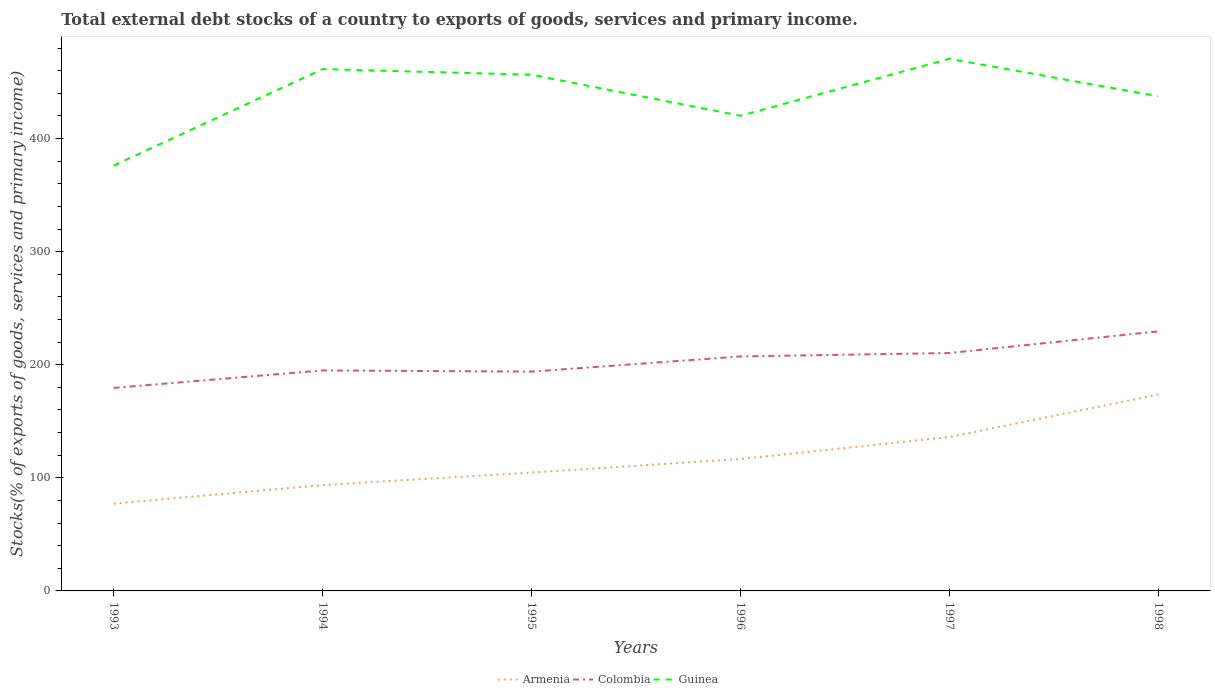Does the line corresponding to Guinea intersect with the line corresponding to Armenia?
Give a very brief answer. No. Is the number of lines equal to the number of legend labels?
Offer a very short reply. Yes. Across all years, what is the maximum total debt stocks in Guinea?
Provide a short and direct response. 376.23. What is the total total debt stocks in Armenia in the graph?
Your answer should be compact. -68.98. What is the difference between the highest and the second highest total debt stocks in Armenia?
Your answer should be compact. 96.45. What is the difference between the highest and the lowest total debt stocks in Armenia?
Provide a succinct answer. 2. How many years are there in the graph?
Your answer should be compact. 6. What is the title of the graph?
Ensure brevity in your answer.  Total external debt stocks of a country to exports of goods, services and primary income. What is the label or title of the X-axis?
Keep it short and to the point. Years. What is the label or title of the Y-axis?
Provide a succinct answer. Stocks(% of exports of goods, services and primary income). What is the Stocks(% of exports of goods, services and primary income) in Armenia in 1993?
Keep it short and to the point. 77.2. What is the Stocks(% of exports of goods, services and primary income) of Colombia in 1993?
Give a very brief answer. 179.52. What is the Stocks(% of exports of goods, services and primary income) of Guinea in 1993?
Make the answer very short. 376.23. What is the Stocks(% of exports of goods, services and primary income) of Armenia in 1994?
Ensure brevity in your answer.  93.59. What is the Stocks(% of exports of goods, services and primary income) in Colombia in 1994?
Give a very brief answer. 194.99. What is the Stocks(% of exports of goods, services and primary income) in Guinea in 1994?
Your answer should be compact. 461.48. What is the Stocks(% of exports of goods, services and primary income) in Armenia in 1995?
Your answer should be compact. 104.67. What is the Stocks(% of exports of goods, services and primary income) in Colombia in 1995?
Your answer should be very brief. 193.93. What is the Stocks(% of exports of goods, services and primary income) in Guinea in 1995?
Your response must be concise. 456.52. What is the Stocks(% of exports of goods, services and primary income) of Armenia in 1996?
Offer a terse response. 116.66. What is the Stocks(% of exports of goods, services and primary income) of Colombia in 1996?
Keep it short and to the point. 207.36. What is the Stocks(% of exports of goods, services and primary income) of Guinea in 1996?
Ensure brevity in your answer.  420.25. What is the Stocks(% of exports of goods, services and primary income) in Armenia in 1997?
Provide a short and direct response. 136.08. What is the Stocks(% of exports of goods, services and primary income) in Colombia in 1997?
Ensure brevity in your answer.  210.38. What is the Stocks(% of exports of goods, services and primary income) of Guinea in 1997?
Provide a succinct answer. 470.56. What is the Stocks(% of exports of goods, services and primary income) in Armenia in 1998?
Provide a succinct answer. 173.65. What is the Stocks(% of exports of goods, services and primary income) of Colombia in 1998?
Make the answer very short. 229.54. What is the Stocks(% of exports of goods, services and primary income) in Guinea in 1998?
Your answer should be very brief. 437.52. Across all years, what is the maximum Stocks(% of exports of goods, services and primary income) in Armenia?
Give a very brief answer. 173.65. Across all years, what is the maximum Stocks(% of exports of goods, services and primary income) in Colombia?
Ensure brevity in your answer.  229.54. Across all years, what is the maximum Stocks(% of exports of goods, services and primary income) in Guinea?
Keep it short and to the point. 470.56. Across all years, what is the minimum Stocks(% of exports of goods, services and primary income) of Armenia?
Offer a terse response. 77.2. Across all years, what is the minimum Stocks(% of exports of goods, services and primary income) of Colombia?
Offer a very short reply. 179.52. Across all years, what is the minimum Stocks(% of exports of goods, services and primary income) in Guinea?
Ensure brevity in your answer.  376.23. What is the total Stocks(% of exports of goods, services and primary income) of Armenia in the graph?
Your answer should be compact. 701.85. What is the total Stocks(% of exports of goods, services and primary income) in Colombia in the graph?
Your response must be concise. 1215.72. What is the total Stocks(% of exports of goods, services and primary income) of Guinea in the graph?
Keep it short and to the point. 2622.56. What is the difference between the Stocks(% of exports of goods, services and primary income) in Armenia in 1993 and that in 1994?
Give a very brief answer. -16.38. What is the difference between the Stocks(% of exports of goods, services and primary income) in Colombia in 1993 and that in 1994?
Ensure brevity in your answer.  -15.47. What is the difference between the Stocks(% of exports of goods, services and primary income) of Guinea in 1993 and that in 1994?
Keep it short and to the point. -85.24. What is the difference between the Stocks(% of exports of goods, services and primary income) of Armenia in 1993 and that in 1995?
Give a very brief answer. -27.46. What is the difference between the Stocks(% of exports of goods, services and primary income) in Colombia in 1993 and that in 1995?
Offer a terse response. -14.4. What is the difference between the Stocks(% of exports of goods, services and primary income) of Guinea in 1993 and that in 1995?
Ensure brevity in your answer.  -80.29. What is the difference between the Stocks(% of exports of goods, services and primary income) of Armenia in 1993 and that in 1996?
Give a very brief answer. -39.46. What is the difference between the Stocks(% of exports of goods, services and primary income) in Colombia in 1993 and that in 1996?
Your response must be concise. -27.84. What is the difference between the Stocks(% of exports of goods, services and primary income) of Guinea in 1993 and that in 1996?
Make the answer very short. -44.02. What is the difference between the Stocks(% of exports of goods, services and primary income) of Armenia in 1993 and that in 1997?
Keep it short and to the point. -58.88. What is the difference between the Stocks(% of exports of goods, services and primary income) in Colombia in 1993 and that in 1997?
Keep it short and to the point. -30.86. What is the difference between the Stocks(% of exports of goods, services and primary income) in Guinea in 1993 and that in 1997?
Ensure brevity in your answer.  -94.32. What is the difference between the Stocks(% of exports of goods, services and primary income) in Armenia in 1993 and that in 1998?
Make the answer very short. -96.45. What is the difference between the Stocks(% of exports of goods, services and primary income) in Colombia in 1993 and that in 1998?
Provide a succinct answer. -50.01. What is the difference between the Stocks(% of exports of goods, services and primary income) of Guinea in 1993 and that in 1998?
Ensure brevity in your answer.  -61.28. What is the difference between the Stocks(% of exports of goods, services and primary income) in Armenia in 1994 and that in 1995?
Give a very brief answer. -11.08. What is the difference between the Stocks(% of exports of goods, services and primary income) in Colombia in 1994 and that in 1995?
Give a very brief answer. 1.07. What is the difference between the Stocks(% of exports of goods, services and primary income) of Guinea in 1994 and that in 1995?
Ensure brevity in your answer.  4.95. What is the difference between the Stocks(% of exports of goods, services and primary income) of Armenia in 1994 and that in 1996?
Ensure brevity in your answer.  -23.08. What is the difference between the Stocks(% of exports of goods, services and primary income) in Colombia in 1994 and that in 1996?
Make the answer very short. -12.37. What is the difference between the Stocks(% of exports of goods, services and primary income) in Guinea in 1994 and that in 1996?
Your answer should be compact. 41.23. What is the difference between the Stocks(% of exports of goods, services and primary income) of Armenia in 1994 and that in 1997?
Give a very brief answer. -42.5. What is the difference between the Stocks(% of exports of goods, services and primary income) in Colombia in 1994 and that in 1997?
Your response must be concise. -15.39. What is the difference between the Stocks(% of exports of goods, services and primary income) of Guinea in 1994 and that in 1997?
Give a very brief answer. -9.08. What is the difference between the Stocks(% of exports of goods, services and primary income) in Armenia in 1994 and that in 1998?
Keep it short and to the point. -80.06. What is the difference between the Stocks(% of exports of goods, services and primary income) of Colombia in 1994 and that in 1998?
Your response must be concise. -34.54. What is the difference between the Stocks(% of exports of goods, services and primary income) in Guinea in 1994 and that in 1998?
Provide a short and direct response. 23.96. What is the difference between the Stocks(% of exports of goods, services and primary income) in Armenia in 1995 and that in 1996?
Give a very brief answer. -12. What is the difference between the Stocks(% of exports of goods, services and primary income) in Colombia in 1995 and that in 1996?
Your answer should be compact. -13.44. What is the difference between the Stocks(% of exports of goods, services and primary income) of Guinea in 1995 and that in 1996?
Ensure brevity in your answer.  36.27. What is the difference between the Stocks(% of exports of goods, services and primary income) in Armenia in 1995 and that in 1997?
Make the answer very short. -31.42. What is the difference between the Stocks(% of exports of goods, services and primary income) of Colombia in 1995 and that in 1997?
Provide a succinct answer. -16.46. What is the difference between the Stocks(% of exports of goods, services and primary income) in Guinea in 1995 and that in 1997?
Make the answer very short. -14.03. What is the difference between the Stocks(% of exports of goods, services and primary income) in Armenia in 1995 and that in 1998?
Offer a very short reply. -68.98. What is the difference between the Stocks(% of exports of goods, services and primary income) in Colombia in 1995 and that in 1998?
Offer a very short reply. -35.61. What is the difference between the Stocks(% of exports of goods, services and primary income) of Guinea in 1995 and that in 1998?
Provide a succinct answer. 19.01. What is the difference between the Stocks(% of exports of goods, services and primary income) of Armenia in 1996 and that in 1997?
Make the answer very short. -19.42. What is the difference between the Stocks(% of exports of goods, services and primary income) of Colombia in 1996 and that in 1997?
Ensure brevity in your answer.  -3.02. What is the difference between the Stocks(% of exports of goods, services and primary income) of Guinea in 1996 and that in 1997?
Provide a succinct answer. -50.3. What is the difference between the Stocks(% of exports of goods, services and primary income) of Armenia in 1996 and that in 1998?
Keep it short and to the point. -56.99. What is the difference between the Stocks(% of exports of goods, services and primary income) of Colombia in 1996 and that in 1998?
Make the answer very short. -22.17. What is the difference between the Stocks(% of exports of goods, services and primary income) in Guinea in 1996 and that in 1998?
Ensure brevity in your answer.  -17.26. What is the difference between the Stocks(% of exports of goods, services and primary income) in Armenia in 1997 and that in 1998?
Your answer should be compact. -37.57. What is the difference between the Stocks(% of exports of goods, services and primary income) of Colombia in 1997 and that in 1998?
Your answer should be very brief. -19.15. What is the difference between the Stocks(% of exports of goods, services and primary income) of Guinea in 1997 and that in 1998?
Offer a very short reply. 33.04. What is the difference between the Stocks(% of exports of goods, services and primary income) in Armenia in 1993 and the Stocks(% of exports of goods, services and primary income) in Colombia in 1994?
Make the answer very short. -117.79. What is the difference between the Stocks(% of exports of goods, services and primary income) in Armenia in 1993 and the Stocks(% of exports of goods, services and primary income) in Guinea in 1994?
Provide a short and direct response. -384.28. What is the difference between the Stocks(% of exports of goods, services and primary income) of Colombia in 1993 and the Stocks(% of exports of goods, services and primary income) of Guinea in 1994?
Make the answer very short. -281.95. What is the difference between the Stocks(% of exports of goods, services and primary income) in Armenia in 1993 and the Stocks(% of exports of goods, services and primary income) in Colombia in 1995?
Give a very brief answer. -116.72. What is the difference between the Stocks(% of exports of goods, services and primary income) in Armenia in 1993 and the Stocks(% of exports of goods, services and primary income) in Guinea in 1995?
Provide a succinct answer. -379.32. What is the difference between the Stocks(% of exports of goods, services and primary income) of Colombia in 1993 and the Stocks(% of exports of goods, services and primary income) of Guinea in 1995?
Ensure brevity in your answer.  -277. What is the difference between the Stocks(% of exports of goods, services and primary income) of Armenia in 1993 and the Stocks(% of exports of goods, services and primary income) of Colombia in 1996?
Make the answer very short. -130.16. What is the difference between the Stocks(% of exports of goods, services and primary income) in Armenia in 1993 and the Stocks(% of exports of goods, services and primary income) in Guinea in 1996?
Keep it short and to the point. -343.05. What is the difference between the Stocks(% of exports of goods, services and primary income) in Colombia in 1993 and the Stocks(% of exports of goods, services and primary income) in Guinea in 1996?
Provide a succinct answer. -240.73. What is the difference between the Stocks(% of exports of goods, services and primary income) of Armenia in 1993 and the Stocks(% of exports of goods, services and primary income) of Colombia in 1997?
Offer a very short reply. -133.18. What is the difference between the Stocks(% of exports of goods, services and primary income) of Armenia in 1993 and the Stocks(% of exports of goods, services and primary income) of Guinea in 1997?
Your response must be concise. -393.35. What is the difference between the Stocks(% of exports of goods, services and primary income) of Colombia in 1993 and the Stocks(% of exports of goods, services and primary income) of Guinea in 1997?
Ensure brevity in your answer.  -291.03. What is the difference between the Stocks(% of exports of goods, services and primary income) in Armenia in 1993 and the Stocks(% of exports of goods, services and primary income) in Colombia in 1998?
Give a very brief answer. -152.33. What is the difference between the Stocks(% of exports of goods, services and primary income) in Armenia in 1993 and the Stocks(% of exports of goods, services and primary income) in Guinea in 1998?
Keep it short and to the point. -360.31. What is the difference between the Stocks(% of exports of goods, services and primary income) in Colombia in 1993 and the Stocks(% of exports of goods, services and primary income) in Guinea in 1998?
Ensure brevity in your answer.  -257.99. What is the difference between the Stocks(% of exports of goods, services and primary income) of Armenia in 1994 and the Stocks(% of exports of goods, services and primary income) of Colombia in 1995?
Keep it short and to the point. -100.34. What is the difference between the Stocks(% of exports of goods, services and primary income) of Armenia in 1994 and the Stocks(% of exports of goods, services and primary income) of Guinea in 1995?
Make the answer very short. -362.94. What is the difference between the Stocks(% of exports of goods, services and primary income) in Colombia in 1994 and the Stocks(% of exports of goods, services and primary income) in Guinea in 1995?
Keep it short and to the point. -261.53. What is the difference between the Stocks(% of exports of goods, services and primary income) in Armenia in 1994 and the Stocks(% of exports of goods, services and primary income) in Colombia in 1996?
Ensure brevity in your answer.  -113.78. What is the difference between the Stocks(% of exports of goods, services and primary income) of Armenia in 1994 and the Stocks(% of exports of goods, services and primary income) of Guinea in 1996?
Provide a short and direct response. -326.67. What is the difference between the Stocks(% of exports of goods, services and primary income) of Colombia in 1994 and the Stocks(% of exports of goods, services and primary income) of Guinea in 1996?
Your response must be concise. -225.26. What is the difference between the Stocks(% of exports of goods, services and primary income) in Armenia in 1994 and the Stocks(% of exports of goods, services and primary income) in Colombia in 1997?
Your answer should be compact. -116.8. What is the difference between the Stocks(% of exports of goods, services and primary income) of Armenia in 1994 and the Stocks(% of exports of goods, services and primary income) of Guinea in 1997?
Provide a succinct answer. -376.97. What is the difference between the Stocks(% of exports of goods, services and primary income) in Colombia in 1994 and the Stocks(% of exports of goods, services and primary income) in Guinea in 1997?
Provide a succinct answer. -275.56. What is the difference between the Stocks(% of exports of goods, services and primary income) in Armenia in 1994 and the Stocks(% of exports of goods, services and primary income) in Colombia in 1998?
Make the answer very short. -135.95. What is the difference between the Stocks(% of exports of goods, services and primary income) in Armenia in 1994 and the Stocks(% of exports of goods, services and primary income) in Guinea in 1998?
Offer a terse response. -343.93. What is the difference between the Stocks(% of exports of goods, services and primary income) of Colombia in 1994 and the Stocks(% of exports of goods, services and primary income) of Guinea in 1998?
Ensure brevity in your answer.  -242.52. What is the difference between the Stocks(% of exports of goods, services and primary income) of Armenia in 1995 and the Stocks(% of exports of goods, services and primary income) of Colombia in 1996?
Keep it short and to the point. -102.7. What is the difference between the Stocks(% of exports of goods, services and primary income) in Armenia in 1995 and the Stocks(% of exports of goods, services and primary income) in Guinea in 1996?
Offer a terse response. -315.59. What is the difference between the Stocks(% of exports of goods, services and primary income) of Colombia in 1995 and the Stocks(% of exports of goods, services and primary income) of Guinea in 1996?
Your answer should be very brief. -226.33. What is the difference between the Stocks(% of exports of goods, services and primary income) of Armenia in 1995 and the Stocks(% of exports of goods, services and primary income) of Colombia in 1997?
Provide a short and direct response. -105.72. What is the difference between the Stocks(% of exports of goods, services and primary income) of Armenia in 1995 and the Stocks(% of exports of goods, services and primary income) of Guinea in 1997?
Offer a terse response. -365.89. What is the difference between the Stocks(% of exports of goods, services and primary income) of Colombia in 1995 and the Stocks(% of exports of goods, services and primary income) of Guinea in 1997?
Your response must be concise. -276.63. What is the difference between the Stocks(% of exports of goods, services and primary income) in Armenia in 1995 and the Stocks(% of exports of goods, services and primary income) in Colombia in 1998?
Provide a succinct answer. -124.87. What is the difference between the Stocks(% of exports of goods, services and primary income) in Armenia in 1995 and the Stocks(% of exports of goods, services and primary income) in Guinea in 1998?
Provide a succinct answer. -332.85. What is the difference between the Stocks(% of exports of goods, services and primary income) in Colombia in 1995 and the Stocks(% of exports of goods, services and primary income) in Guinea in 1998?
Offer a terse response. -243.59. What is the difference between the Stocks(% of exports of goods, services and primary income) of Armenia in 1996 and the Stocks(% of exports of goods, services and primary income) of Colombia in 1997?
Your answer should be compact. -93.72. What is the difference between the Stocks(% of exports of goods, services and primary income) of Armenia in 1996 and the Stocks(% of exports of goods, services and primary income) of Guinea in 1997?
Keep it short and to the point. -353.89. What is the difference between the Stocks(% of exports of goods, services and primary income) of Colombia in 1996 and the Stocks(% of exports of goods, services and primary income) of Guinea in 1997?
Your answer should be very brief. -263.19. What is the difference between the Stocks(% of exports of goods, services and primary income) in Armenia in 1996 and the Stocks(% of exports of goods, services and primary income) in Colombia in 1998?
Keep it short and to the point. -112.87. What is the difference between the Stocks(% of exports of goods, services and primary income) in Armenia in 1996 and the Stocks(% of exports of goods, services and primary income) in Guinea in 1998?
Your answer should be very brief. -320.85. What is the difference between the Stocks(% of exports of goods, services and primary income) in Colombia in 1996 and the Stocks(% of exports of goods, services and primary income) in Guinea in 1998?
Provide a succinct answer. -230.15. What is the difference between the Stocks(% of exports of goods, services and primary income) of Armenia in 1997 and the Stocks(% of exports of goods, services and primary income) of Colombia in 1998?
Your answer should be compact. -93.45. What is the difference between the Stocks(% of exports of goods, services and primary income) in Armenia in 1997 and the Stocks(% of exports of goods, services and primary income) in Guinea in 1998?
Make the answer very short. -301.43. What is the difference between the Stocks(% of exports of goods, services and primary income) in Colombia in 1997 and the Stocks(% of exports of goods, services and primary income) in Guinea in 1998?
Your response must be concise. -227.13. What is the average Stocks(% of exports of goods, services and primary income) in Armenia per year?
Give a very brief answer. 116.98. What is the average Stocks(% of exports of goods, services and primary income) in Colombia per year?
Provide a short and direct response. 202.62. What is the average Stocks(% of exports of goods, services and primary income) of Guinea per year?
Provide a short and direct response. 437.09. In the year 1993, what is the difference between the Stocks(% of exports of goods, services and primary income) in Armenia and Stocks(% of exports of goods, services and primary income) in Colombia?
Your response must be concise. -102.32. In the year 1993, what is the difference between the Stocks(% of exports of goods, services and primary income) of Armenia and Stocks(% of exports of goods, services and primary income) of Guinea?
Provide a short and direct response. -299.03. In the year 1993, what is the difference between the Stocks(% of exports of goods, services and primary income) in Colombia and Stocks(% of exports of goods, services and primary income) in Guinea?
Ensure brevity in your answer.  -196.71. In the year 1994, what is the difference between the Stocks(% of exports of goods, services and primary income) of Armenia and Stocks(% of exports of goods, services and primary income) of Colombia?
Your answer should be compact. -101.41. In the year 1994, what is the difference between the Stocks(% of exports of goods, services and primary income) of Armenia and Stocks(% of exports of goods, services and primary income) of Guinea?
Your response must be concise. -367.89. In the year 1994, what is the difference between the Stocks(% of exports of goods, services and primary income) in Colombia and Stocks(% of exports of goods, services and primary income) in Guinea?
Provide a succinct answer. -266.49. In the year 1995, what is the difference between the Stocks(% of exports of goods, services and primary income) of Armenia and Stocks(% of exports of goods, services and primary income) of Colombia?
Your response must be concise. -89.26. In the year 1995, what is the difference between the Stocks(% of exports of goods, services and primary income) of Armenia and Stocks(% of exports of goods, services and primary income) of Guinea?
Keep it short and to the point. -351.86. In the year 1995, what is the difference between the Stocks(% of exports of goods, services and primary income) in Colombia and Stocks(% of exports of goods, services and primary income) in Guinea?
Your response must be concise. -262.6. In the year 1996, what is the difference between the Stocks(% of exports of goods, services and primary income) of Armenia and Stocks(% of exports of goods, services and primary income) of Colombia?
Offer a very short reply. -90.7. In the year 1996, what is the difference between the Stocks(% of exports of goods, services and primary income) in Armenia and Stocks(% of exports of goods, services and primary income) in Guinea?
Offer a very short reply. -303.59. In the year 1996, what is the difference between the Stocks(% of exports of goods, services and primary income) in Colombia and Stocks(% of exports of goods, services and primary income) in Guinea?
Your response must be concise. -212.89. In the year 1997, what is the difference between the Stocks(% of exports of goods, services and primary income) of Armenia and Stocks(% of exports of goods, services and primary income) of Colombia?
Offer a very short reply. -74.3. In the year 1997, what is the difference between the Stocks(% of exports of goods, services and primary income) in Armenia and Stocks(% of exports of goods, services and primary income) in Guinea?
Offer a terse response. -334.47. In the year 1997, what is the difference between the Stocks(% of exports of goods, services and primary income) in Colombia and Stocks(% of exports of goods, services and primary income) in Guinea?
Offer a very short reply. -260.17. In the year 1998, what is the difference between the Stocks(% of exports of goods, services and primary income) in Armenia and Stocks(% of exports of goods, services and primary income) in Colombia?
Provide a succinct answer. -55.89. In the year 1998, what is the difference between the Stocks(% of exports of goods, services and primary income) in Armenia and Stocks(% of exports of goods, services and primary income) in Guinea?
Make the answer very short. -263.87. In the year 1998, what is the difference between the Stocks(% of exports of goods, services and primary income) of Colombia and Stocks(% of exports of goods, services and primary income) of Guinea?
Your answer should be very brief. -207.98. What is the ratio of the Stocks(% of exports of goods, services and primary income) in Armenia in 1993 to that in 1994?
Your answer should be very brief. 0.82. What is the ratio of the Stocks(% of exports of goods, services and primary income) of Colombia in 1993 to that in 1994?
Give a very brief answer. 0.92. What is the ratio of the Stocks(% of exports of goods, services and primary income) of Guinea in 1993 to that in 1994?
Your answer should be very brief. 0.82. What is the ratio of the Stocks(% of exports of goods, services and primary income) of Armenia in 1993 to that in 1995?
Offer a terse response. 0.74. What is the ratio of the Stocks(% of exports of goods, services and primary income) of Colombia in 1993 to that in 1995?
Offer a terse response. 0.93. What is the ratio of the Stocks(% of exports of goods, services and primary income) in Guinea in 1993 to that in 1995?
Give a very brief answer. 0.82. What is the ratio of the Stocks(% of exports of goods, services and primary income) of Armenia in 1993 to that in 1996?
Provide a short and direct response. 0.66. What is the ratio of the Stocks(% of exports of goods, services and primary income) in Colombia in 1993 to that in 1996?
Your answer should be compact. 0.87. What is the ratio of the Stocks(% of exports of goods, services and primary income) in Guinea in 1993 to that in 1996?
Provide a short and direct response. 0.9. What is the ratio of the Stocks(% of exports of goods, services and primary income) of Armenia in 1993 to that in 1997?
Provide a short and direct response. 0.57. What is the ratio of the Stocks(% of exports of goods, services and primary income) of Colombia in 1993 to that in 1997?
Provide a succinct answer. 0.85. What is the ratio of the Stocks(% of exports of goods, services and primary income) of Guinea in 1993 to that in 1997?
Offer a very short reply. 0.8. What is the ratio of the Stocks(% of exports of goods, services and primary income) in Armenia in 1993 to that in 1998?
Give a very brief answer. 0.44. What is the ratio of the Stocks(% of exports of goods, services and primary income) in Colombia in 1993 to that in 1998?
Your answer should be very brief. 0.78. What is the ratio of the Stocks(% of exports of goods, services and primary income) in Guinea in 1993 to that in 1998?
Give a very brief answer. 0.86. What is the ratio of the Stocks(% of exports of goods, services and primary income) in Armenia in 1994 to that in 1995?
Give a very brief answer. 0.89. What is the ratio of the Stocks(% of exports of goods, services and primary income) of Guinea in 1994 to that in 1995?
Your response must be concise. 1.01. What is the ratio of the Stocks(% of exports of goods, services and primary income) in Armenia in 1994 to that in 1996?
Ensure brevity in your answer.  0.8. What is the ratio of the Stocks(% of exports of goods, services and primary income) of Colombia in 1994 to that in 1996?
Your answer should be very brief. 0.94. What is the ratio of the Stocks(% of exports of goods, services and primary income) of Guinea in 1994 to that in 1996?
Offer a terse response. 1.1. What is the ratio of the Stocks(% of exports of goods, services and primary income) in Armenia in 1994 to that in 1997?
Provide a succinct answer. 0.69. What is the ratio of the Stocks(% of exports of goods, services and primary income) in Colombia in 1994 to that in 1997?
Offer a terse response. 0.93. What is the ratio of the Stocks(% of exports of goods, services and primary income) in Guinea in 1994 to that in 1997?
Your response must be concise. 0.98. What is the ratio of the Stocks(% of exports of goods, services and primary income) in Armenia in 1994 to that in 1998?
Give a very brief answer. 0.54. What is the ratio of the Stocks(% of exports of goods, services and primary income) in Colombia in 1994 to that in 1998?
Provide a succinct answer. 0.85. What is the ratio of the Stocks(% of exports of goods, services and primary income) of Guinea in 1994 to that in 1998?
Provide a short and direct response. 1.05. What is the ratio of the Stocks(% of exports of goods, services and primary income) of Armenia in 1995 to that in 1996?
Keep it short and to the point. 0.9. What is the ratio of the Stocks(% of exports of goods, services and primary income) in Colombia in 1995 to that in 1996?
Your answer should be very brief. 0.94. What is the ratio of the Stocks(% of exports of goods, services and primary income) of Guinea in 1995 to that in 1996?
Offer a very short reply. 1.09. What is the ratio of the Stocks(% of exports of goods, services and primary income) of Armenia in 1995 to that in 1997?
Keep it short and to the point. 0.77. What is the ratio of the Stocks(% of exports of goods, services and primary income) in Colombia in 1995 to that in 1997?
Provide a succinct answer. 0.92. What is the ratio of the Stocks(% of exports of goods, services and primary income) of Guinea in 1995 to that in 1997?
Your answer should be compact. 0.97. What is the ratio of the Stocks(% of exports of goods, services and primary income) of Armenia in 1995 to that in 1998?
Keep it short and to the point. 0.6. What is the ratio of the Stocks(% of exports of goods, services and primary income) of Colombia in 1995 to that in 1998?
Give a very brief answer. 0.84. What is the ratio of the Stocks(% of exports of goods, services and primary income) in Guinea in 1995 to that in 1998?
Provide a short and direct response. 1.04. What is the ratio of the Stocks(% of exports of goods, services and primary income) in Armenia in 1996 to that in 1997?
Give a very brief answer. 0.86. What is the ratio of the Stocks(% of exports of goods, services and primary income) in Colombia in 1996 to that in 1997?
Provide a short and direct response. 0.99. What is the ratio of the Stocks(% of exports of goods, services and primary income) in Guinea in 1996 to that in 1997?
Ensure brevity in your answer.  0.89. What is the ratio of the Stocks(% of exports of goods, services and primary income) of Armenia in 1996 to that in 1998?
Your answer should be compact. 0.67. What is the ratio of the Stocks(% of exports of goods, services and primary income) in Colombia in 1996 to that in 1998?
Offer a terse response. 0.9. What is the ratio of the Stocks(% of exports of goods, services and primary income) in Guinea in 1996 to that in 1998?
Ensure brevity in your answer.  0.96. What is the ratio of the Stocks(% of exports of goods, services and primary income) in Armenia in 1997 to that in 1998?
Provide a succinct answer. 0.78. What is the ratio of the Stocks(% of exports of goods, services and primary income) of Colombia in 1997 to that in 1998?
Ensure brevity in your answer.  0.92. What is the ratio of the Stocks(% of exports of goods, services and primary income) of Guinea in 1997 to that in 1998?
Provide a succinct answer. 1.08. What is the difference between the highest and the second highest Stocks(% of exports of goods, services and primary income) in Armenia?
Provide a succinct answer. 37.57. What is the difference between the highest and the second highest Stocks(% of exports of goods, services and primary income) in Colombia?
Your answer should be very brief. 19.15. What is the difference between the highest and the second highest Stocks(% of exports of goods, services and primary income) in Guinea?
Your answer should be compact. 9.08. What is the difference between the highest and the lowest Stocks(% of exports of goods, services and primary income) in Armenia?
Provide a succinct answer. 96.45. What is the difference between the highest and the lowest Stocks(% of exports of goods, services and primary income) in Colombia?
Make the answer very short. 50.01. What is the difference between the highest and the lowest Stocks(% of exports of goods, services and primary income) in Guinea?
Your answer should be compact. 94.32. 